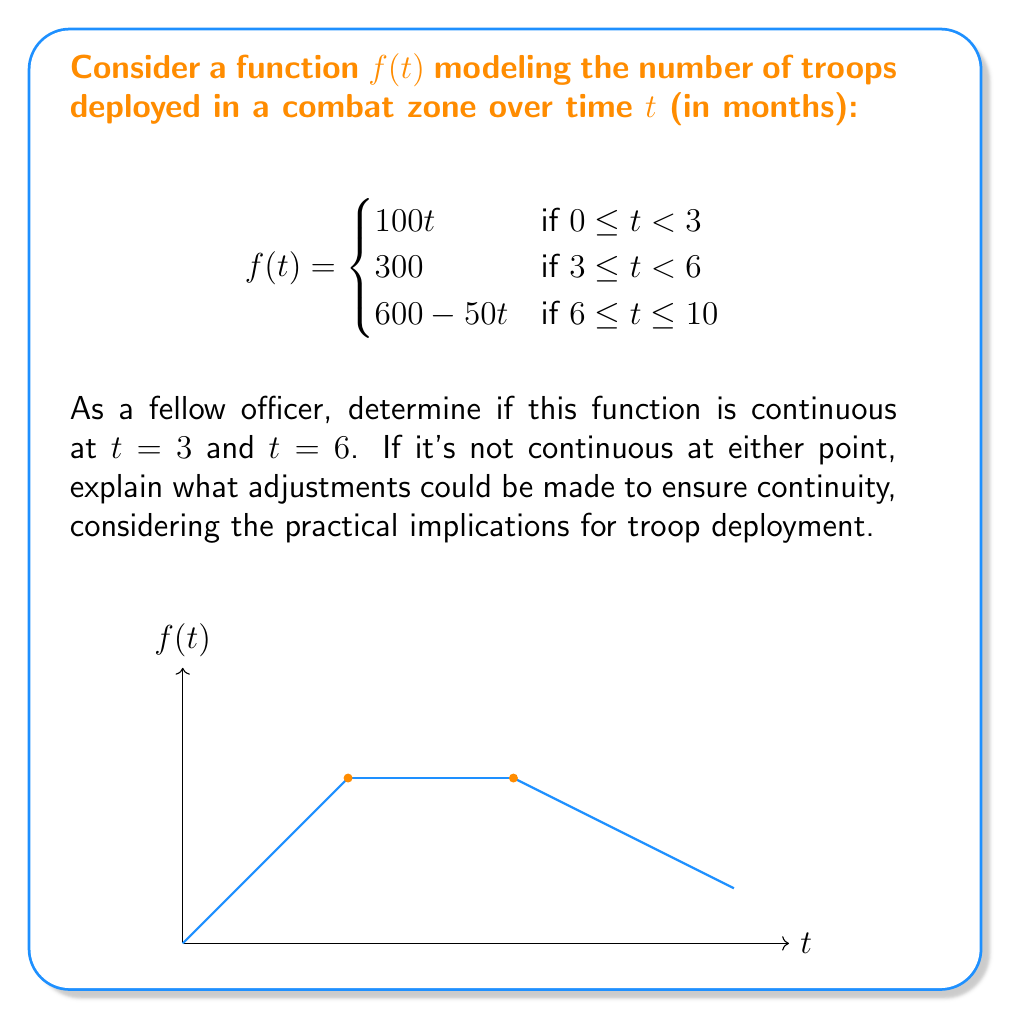Solve this math problem. Let's approach this step-by-step:

1) For a function to be continuous at a point, it must satisfy three conditions:
   a) The function must be defined at that point
   b) The limit of the function as we approach the point from both sides must exist
   c) The limit must equal the function's value at that point

2) At $t = 3$:
   a) Left-hand limit: $\lim_{t \to 3^-} f(t) = \lim_{t \to 3^-} 100t = 300$
   b) Right-hand limit: $\lim_{t \to 3^+} f(t) = 300$
   c) Function value: $f(3) = 300$

   All three conditions are met, so $f(t)$ is continuous at $t = 3$.

3) At $t = 6$:
   a) Left-hand limit: $\lim_{t \to 6^-} f(t) = 300$
   b) Right-hand limit: $\lim_{t \to 6^+} f(t) = \lim_{t \to 6^+} (600 - 50t) = 300$
   c) Function value: $f(6) = 300$

   All three conditions are met, so $f(t)$ is continuous at $t = 6$.

4) The function is continuous at both points, which is ideal for troop deployment planning. It ensures smooth transitions between deployment phases without sudden jumps in troop numbers.

5) If the function were not continuous at either point, we could adjust it by:
   a) Changing the function value at the point of discontinuity to match the limits
   b) Modifying the surrounding pieces to make the limits match the function value

   For example, if $f(6)$ were 350 instead of 300, we could adjust the third piece to be $650 - 50t$ to maintain continuity.
Answer: The function is continuous at both $t = 3$ and $t = 6$. 